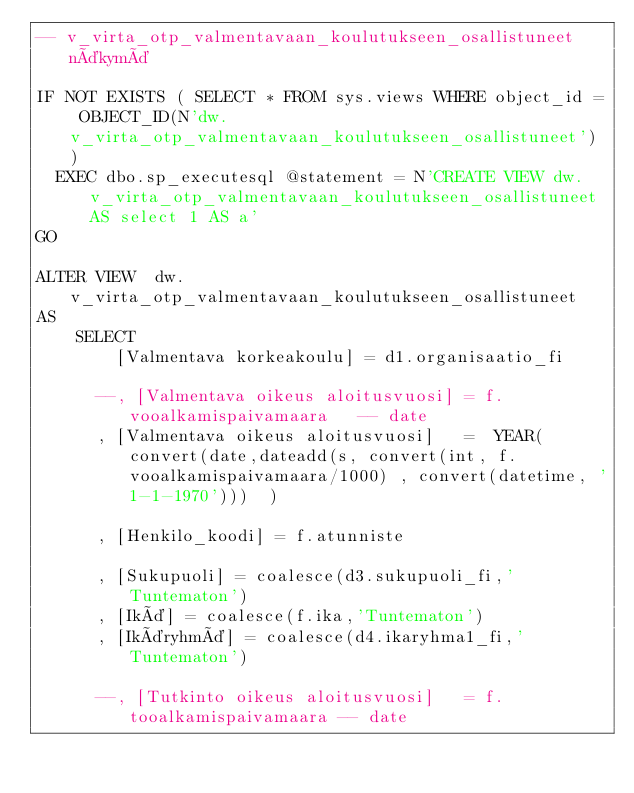Convert code to text. <code><loc_0><loc_0><loc_500><loc_500><_SQL_>-- v_virta_otp_valmentavaan_koulutukseen_osallistuneet näkymä

IF NOT EXISTS ( SELECT * FROM sys.views WHERE object_id = OBJECT_ID(N'dw.v_virta_otp_valmentavaan_koulutukseen_osallistuneet') )
	EXEC dbo.sp_executesql @statement = N'CREATE VIEW dw.v_virta_otp_valmentavaan_koulutukseen_osallistuneet AS select 1 AS a'
GO

ALTER VIEW  dw.v_virta_otp_valmentavaan_koulutukseen_osallistuneet 
AS
		SELECT   			 		   
			  [Valmentava korkeakoulu] = d1.organisaatio_fi
			  
			--, [Valmentava oikeus aloitusvuosi] = f.vooalkamispaivamaara		-- date
			, [Valmentava oikeus aloitusvuosi]   =  YEAR(convert(date,dateadd(s, convert(int, f.vooalkamispaivamaara/1000) , convert(datetime, '1-1-1970')))  )
			
			, [Henkilo_koodi] = f.atunniste
			
			, [Sukupuoli] = coalesce(d3.sukupuoli_fi,'Tuntematon')
			, [Ikä] = coalesce(f.ika,'Tuntematon')
			, [Ikäryhmä] = coalesce(d4.ikaryhma1_fi,'Tuntematon')		
			
			--, [Tutkinto oikeus aloitusvuosi]   = f.tooalkamispaivamaara	-- date	</code> 